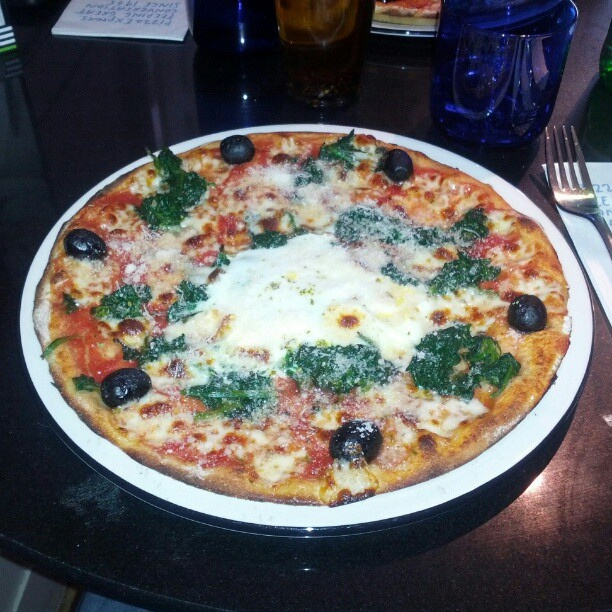Describe the objects in this image and their specific colors. I can see dining table in black, white, gray, and darkgray tones, pizza in black, ivory, darkgray, brown, and tan tones, cup in black, navy, and purple tones, cup in black, maroon, gray, and darkgreen tones, and fork in black, gray, lightgray, and darkgray tones in this image. 